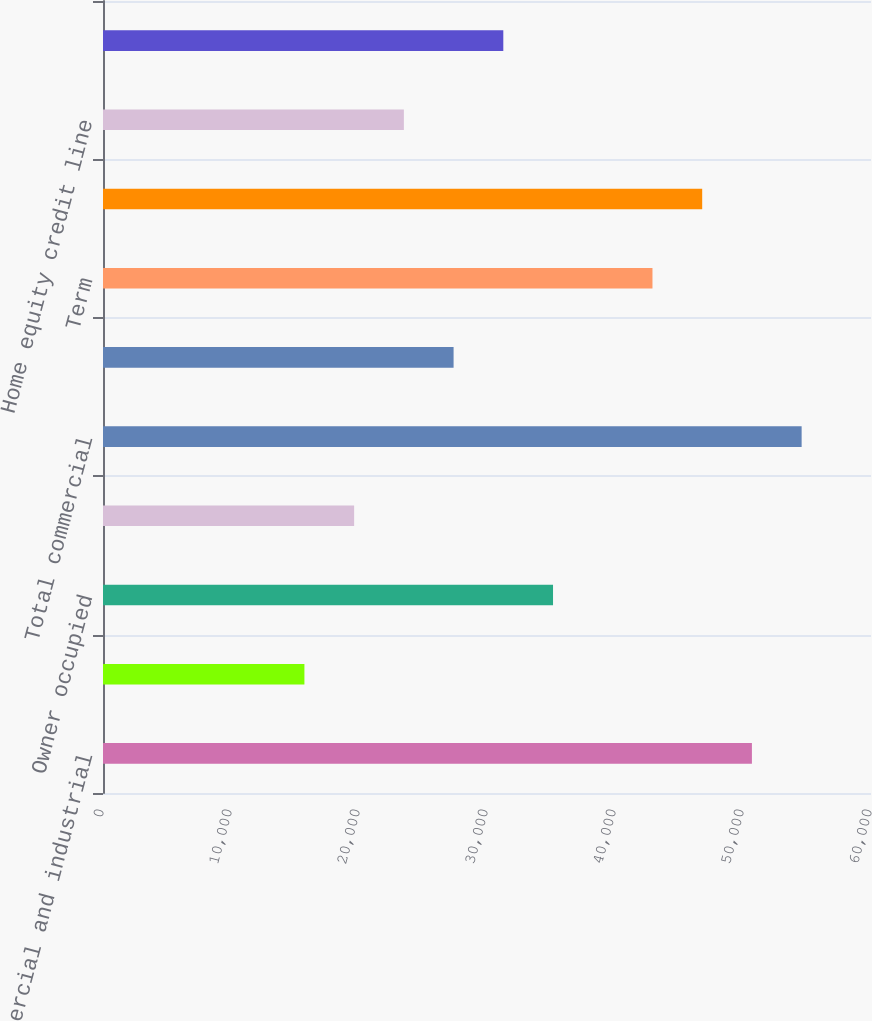<chart> <loc_0><loc_0><loc_500><loc_500><bar_chart><fcel>Commercial and industrial<fcel>Leasing<fcel>Owner occupied<fcel>Municipal<fcel>Total commercial<fcel>Construction and land<fcel>Term<fcel>Total commercial real estate<fcel>Home equity credit line<fcel>1-4 family residential<nl><fcel>50696.5<fcel>15736<fcel>35158.5<fcel>19620.5<fcel>54581<fcel>27389.5<fcel>42927.5<fcel>46812<fcel>23505<fcel>31274<nl></chart> 